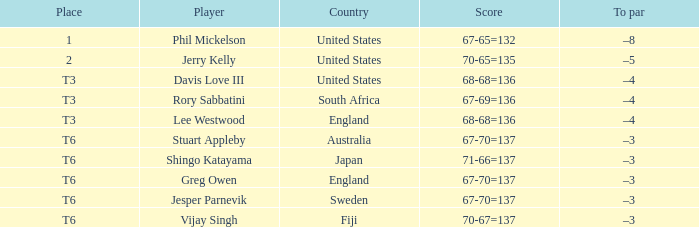Name the score for fiji 70-67=137. 